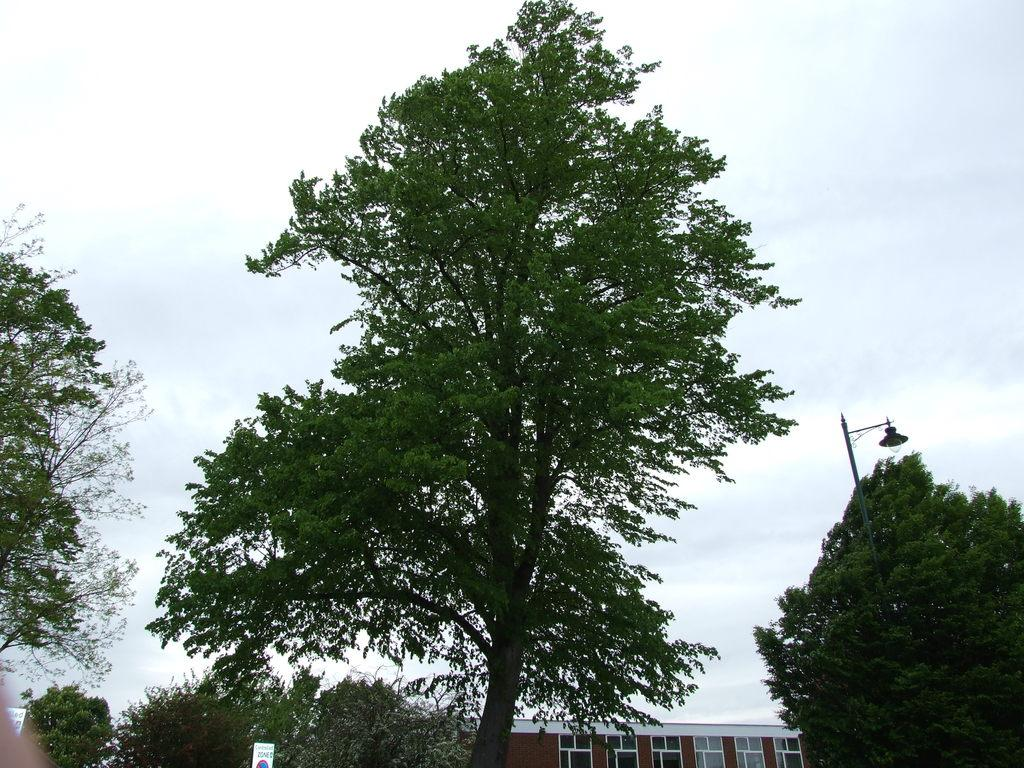What type of vegetation can be seen in the image? There are trees in the image. What is located on the right side of the image? There is a black color pole on the right side of the image. What can be seen in the background of the image? There is a building and the sky visible in the background of the image. What direction is the note pointing in the image? There is no note present in the image. What type of furniture can be seen in the bedroom in the image? There is no bedroom present in the image. 